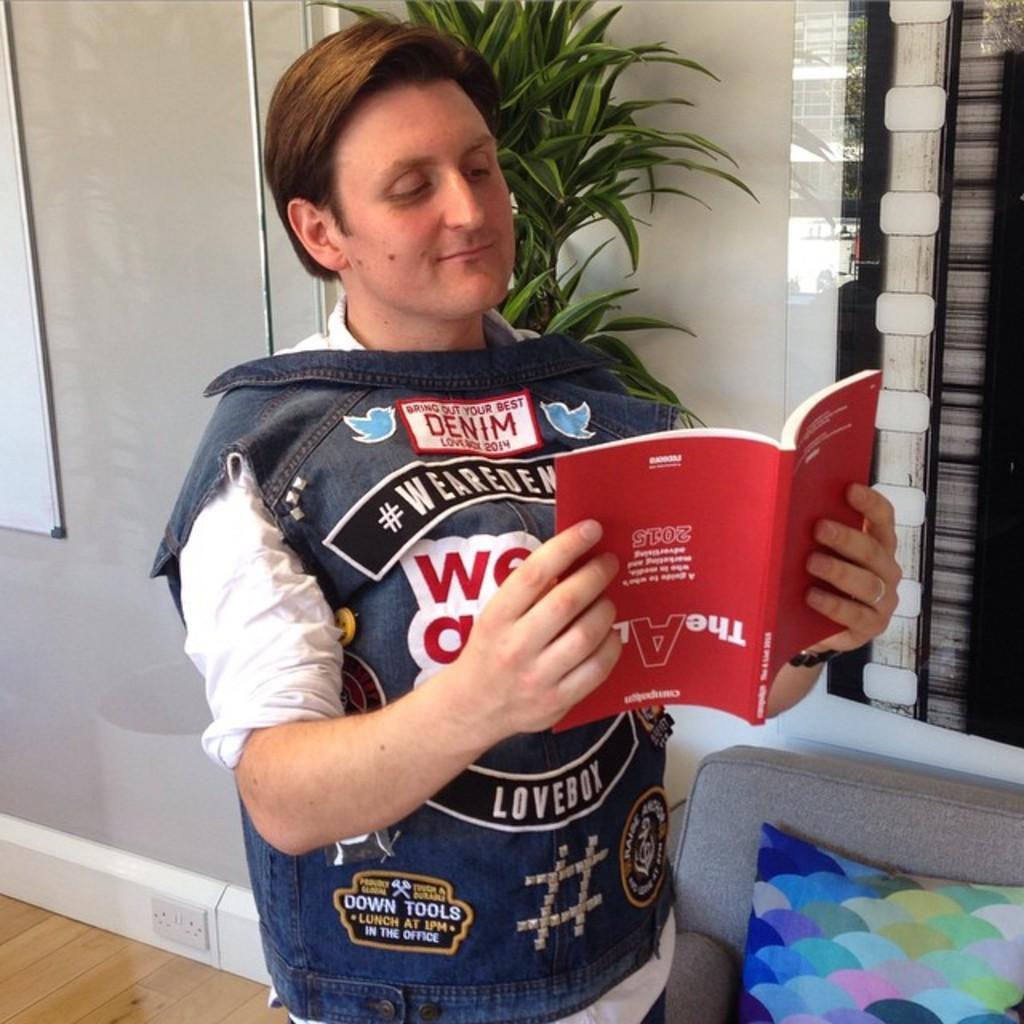Please provide a concise description of this image. In this picture I can see a man holding a book in his hand and looks like a chair and a cushion on it and I can see a plant in the back and looks like a white board on the left side. 